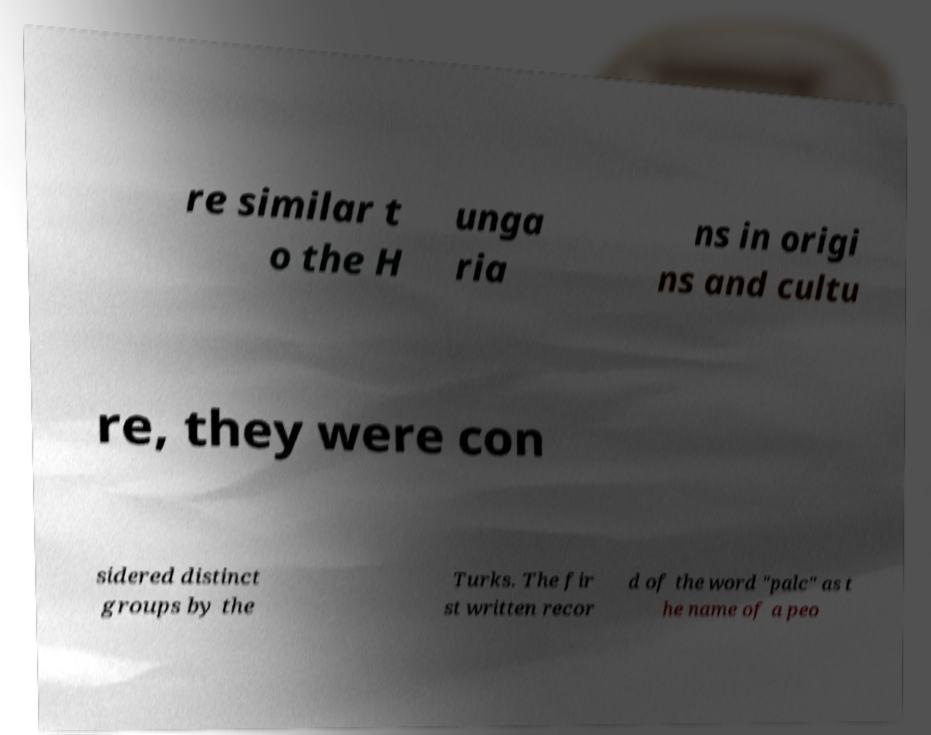Could you assist in decoding the text presented in this image and type it out clearly? re similar t o the H unga ria ns in origi ns and cultu re, they were con sidered distinct groups by the Turks. The fir st written recor d of the word "palc" as t he name of a peo 